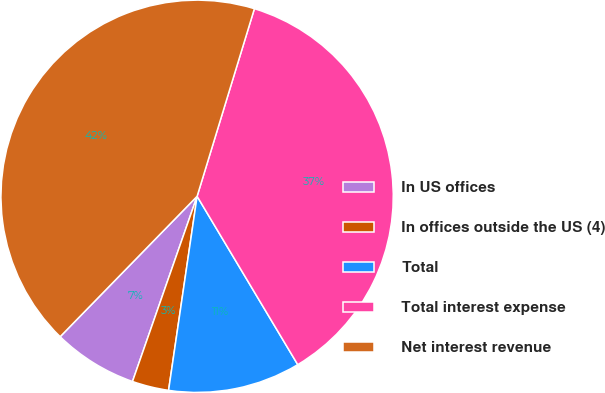Convert chart to OTSL. <chart><loc_0><loc_0><loc_500><loc_500><pie_chart><fcel>In US offices<fcel>In offices outside the US (4)<fcel>Total<fcel>Total interest expense<fcel>Net interest revenue<nl><fcel>6.96%<fcel>3.02%<fcel>10.9%<fcel>36.71%<fcel>42.42%<nl></chart> 